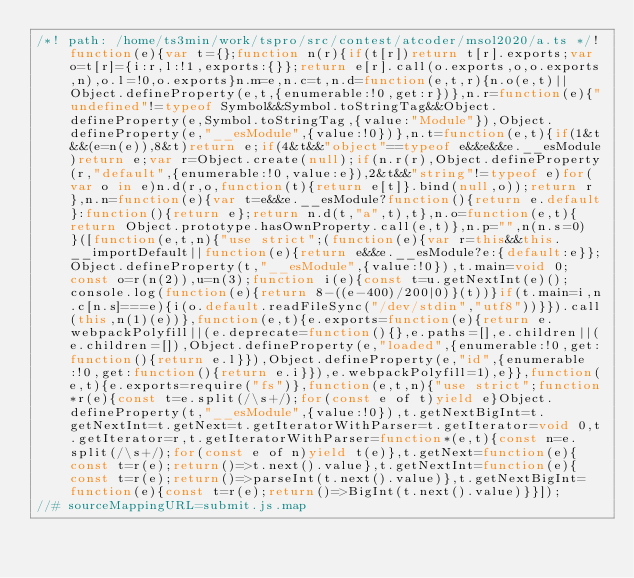<code> <loc_0><loc_0><loc_500><loc_500><_JavaScript_>/*! path: /home/ts3min/work/tspro/src/contest/atcoder/msol2020/a.ts */!function(e){var t={};function n(r){if(t[r])return t[r].exports;var o=t[r]={i:r,l:!1,exports:{}};return e[r].call(o.exports,o,o.exports,n),o.l=!0,o.exports}n.m=e,n.c=t,n.d=function(e,t,r){n.o(e,t)||Object.defineProperty(e,t,{enumerable:!0,get:r})},n.r=function(e){"undefined"!=typeof Symbol&&Symbol.toStringTag&&Object.defineProperty(e,Symbol.toStringTag,{value:"Module"}),Object.defineProperty(e,"__esModule",{value:!0})},n.t=function(e,t){if(1&t&&(e=n(e)),8&t)return e;if(4&t&&"object"==typeof e&&e&&e.__esModule)return e;var r=Object.create(null);if(n.r(r),Object.defineProperty(r,"default",{enumerable:!0,value:e}),2&t&&"string"!=typeof e)for(var o in e)n.d(r,o,function(t){return e[t]}.bind(null,o));return r},n.n=function(e){var t=e&&e.__esModule?function(){return e.default}:function(){return e};return n.d(t,"a",t),t},n.o=function(e,t){return Object.prototype.hasOwnProperty.call(e,t)},n.p="",n(n.s=0)}([function(e,t,n){"use strict";(function(e){var r=this&&this.__importDefault||function(e){return e&&e.__esModule?e:{default:e}};Object.defineProperty(t,"__esModule",{value:!0}),t.main=void 0;const o=r(n(2)),u=n(3);function i(e){const t=u.getNextInt(e)();console.log(function(e){return 8-((e-400)/200|0)}(t))}if(t.main=i,n.c[n.s]===e){i(o.default.readFileSync("/dev/stdin","utf8"))}}).call(this,n(1)(e))},function(e,t){e.exports=function(e){return e.webpackPolyfill||(e.deprecate=function(){},e.paths=[],e.children||(e.children=[]),Object.defineProperty(e,"loaded",{enumerable:!0,get:function(){return e.l}}),Object.defineProperty(e,"id",{enumerable:!0,get:function(){return e.i}}),e.webpackPolyfill=1),e}},function(e,t){e.exports=require("fs")},function(e,t,n){"use strict";function*r(e){const t=e.split(/\s+/);for(const e of t)yield e}Object.defineProperty(t,"__esModule",{value:!0}),t.getNextBigInt=t.getNextInt=t.getNext=t.getIteratorWithParser=t.getIterator=void 0,t.getIterator=r,t.getIteratorWithParser=function*(e,t){const n=e.split(/\s+/);for(const e of n)yield t(e)},t.getNext=function(e){const t=r(e);return()=>t.next().value},t.getNextInt=function(e){const t=r(e);return()=>parseInt(t.next().value)},t.getNextBigInt=function(e){const t=r(e);return()=>BigInt(t.next().value)}}]);
//# sourceMappingURL=submit.js.map</code> 